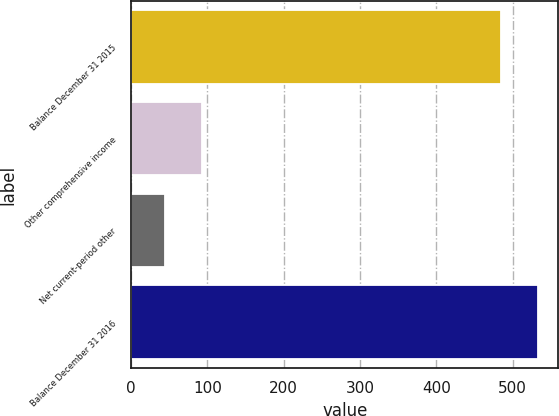<chart> <loc_0><loc_0><loc_500><loc_500><bar_chart><fcel>Balance December 31 2015<fcel>Other comprehensive income<fcel>Net current-period other<fcel>Balance December 31 2016<nl><fcel>484.8<fcel>92.58<fcel>44.1<fcel>533.28<nl></chart> 